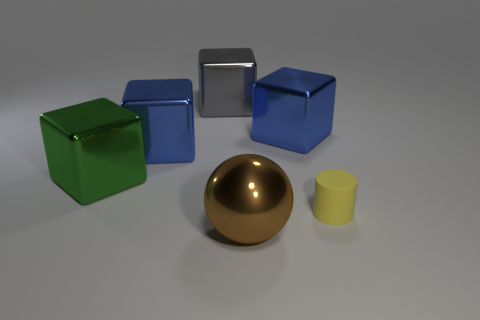What materials do the objects in the image appear to be made of? The objects in the image seem to have a variety of textures and illumination, suggesting that they could be made from different materials. The shiny, reflective surface of the golden sphere alludes to a polished metal construction, while the cubes with less reflection and a slight matte finish might represent plastic or painted wood. The silver cube has a chrome-like finish, which suggests metal as well. 